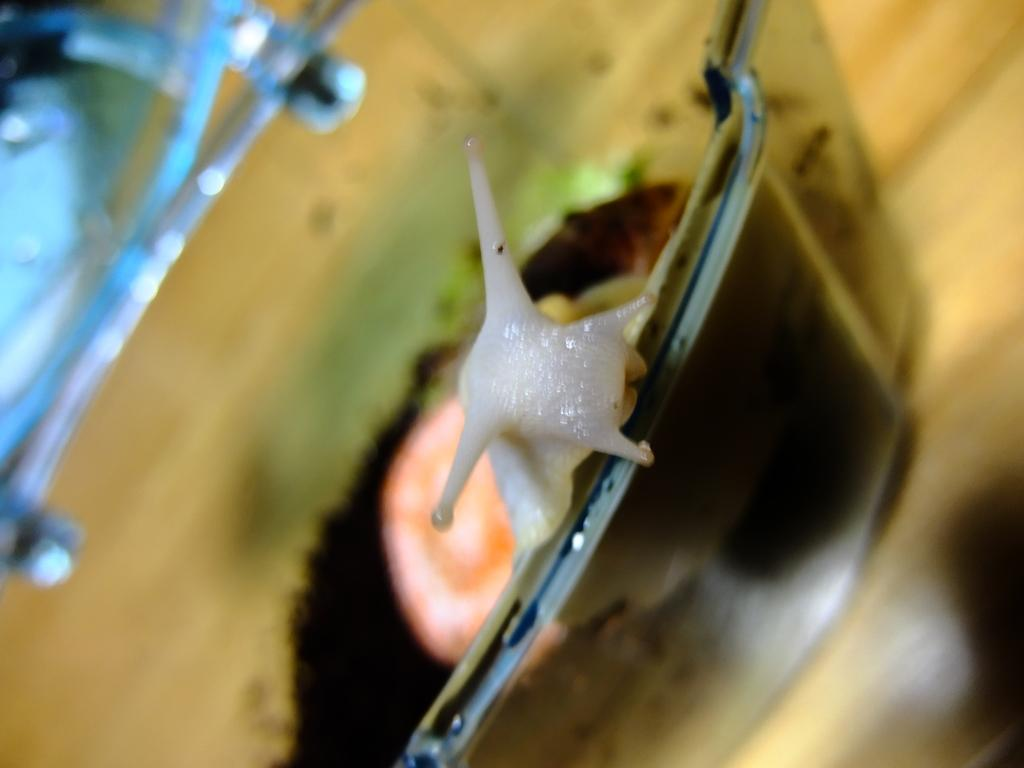What is the main subject of the image? There is a snail in the image. Can you describe the background of the image? The background of the image is blurred. How many boys are playing with yarn in the image? There are no boys or yarn present in the image; it features a snail with a blurred background. Can you describe the frog's behavior in the image? There is no frog present in the image; it features a snail with a blurred background. 